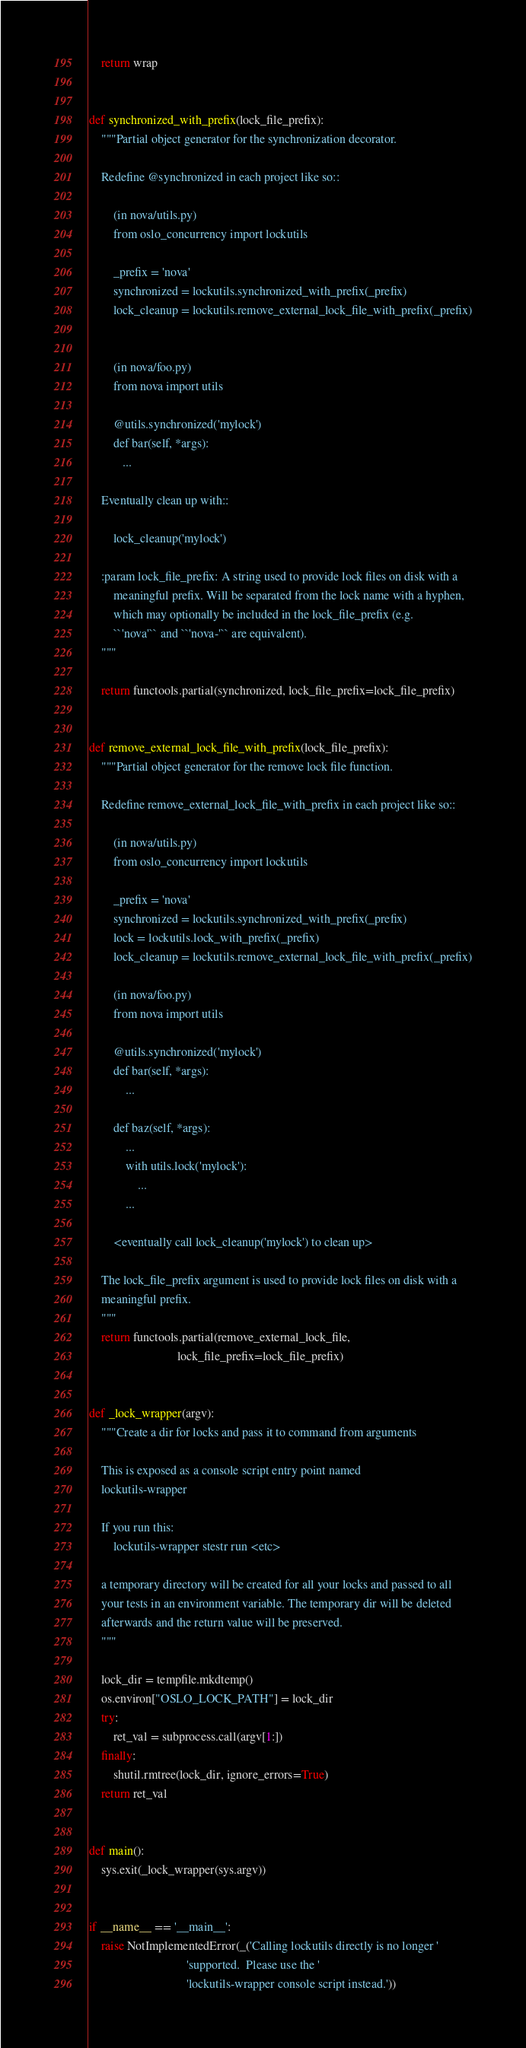<code> <loc_0><loc_0><loc_500><loc_500><_Python_>
    return wrap


def synchronized_with_prefix(lock_file_prefix):
    """Partial object generator for the synchronization decorator.

    Redefine @synchronized in each project like so::

        (in nova/utils.py)
        from oslo_concurrency import lockutils

        _prefix = 'nova'
        synchronized = lockutils.synchronized_with_prefix(_prefix)
        lock_cleanup = lockutils.remove_external_lock_file_with_prefix(_prefix)


        (in nova/foo.py)
        from nova import utils

        @utils.synchronized('mylock')
        def bar(self, *args):
           ...

    Eventually clean up with::

        lock_cleanup('mylock')

    :param lock_file_prefix: A string used to provide lock files on disk with a
        meaningful prefix. Will be separated from the lock name with a hyphen,
        which may optionally be included in the lock_file_prefix (e.g.
        ``'nova'`` and ``'nova-'`` are equivalent).
    """

    return functools.partial(synchronized, lock_file_prefix=lock_file_prefix)


def remove_external_lock_file_with_prefix(lock_file_prefix):
    """Partial object generator for the remove lock file function.

    Redefine remove_external_lock_file_with_prefix in each project like so::

        (in nova/utils.py)
        from oslo_concurrency import lockutils

        _prefix = 'nova'
        synchronized = lockutils.synchronized_with_prefix(_prefix)
        lock = lockutils.lock_with_prefix(_prefix)
        lock_cleanup = lockutils.remove_external_lock_file_with_prefix(_prefix)

        (in nova/foo.py)
        from nova import utils

        @utils.synchronized('mylock')
        def bar(self, *args):
            ...

        def baz(self, *args):
            ...
            with utils.lock('mylock'):
                ...
            ...

        <eventually call lock_cleanup('mylock') to clean up>

    The lock_file_prefix argument is used to provide lock files on disk with a
    meaningful prefix.
    """
    return functools.partial(remove_external_lock_file,
                             lock_file_prefix=lock_file_prefix)


def _lock_wrapper(argv):
    """Create a dir for locks and pass it to command from arguments

    This is exposed as a console script entry point named
    lockutils-wrapper

    If you run this:
        lockutils-wrapper stestr run <etc>

    a temporary directory will be created for all your locks and passed to all
    your tests in an environment variable. The temporary dir will be deleted
    afterwards and the return value will be preserved.
    """

    lock_dir = tempfile.mkdtemp()
    os.environ["OSLO_LOCK_PATH"] = lock_dir
    try:
        ret_val = subprocess.call(argv[1:])
    finally:
        shutil.rmtree(lock_dir, ignore_errors=True)
    return ret_val


def main():
    sys.exit(_lock_wrapper(sys.argv))


if __name__ == '__main__':
    raise NotImplementedError(_('Calling lockutils directly is no longer '
                                'supported.  Please use the '
                                'lockutils-wrapper console script instead.'))
</code> 